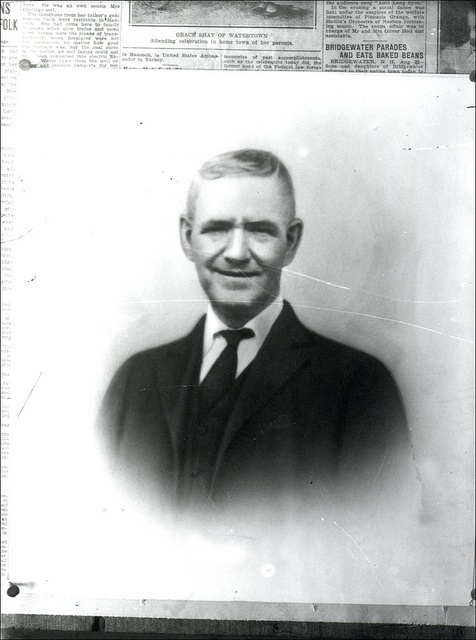Describe the objects in this image and their specific colors. I can see people in black, darkgray, gray, and lightgray tones and tie in black and gray tones in this image. 